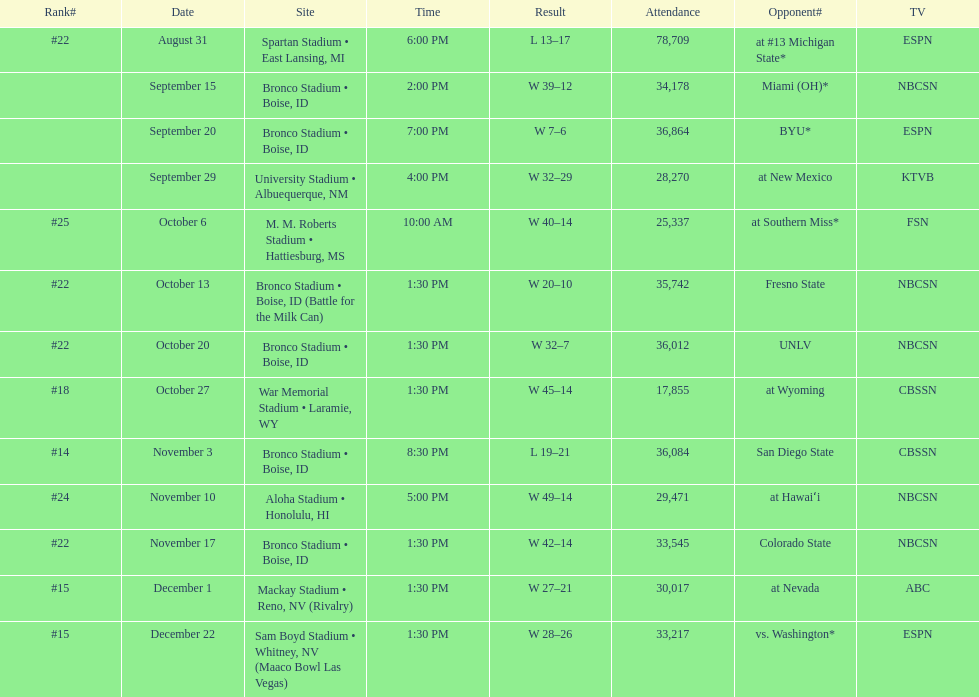What is the total number of games played at bronco stadium? 6. 